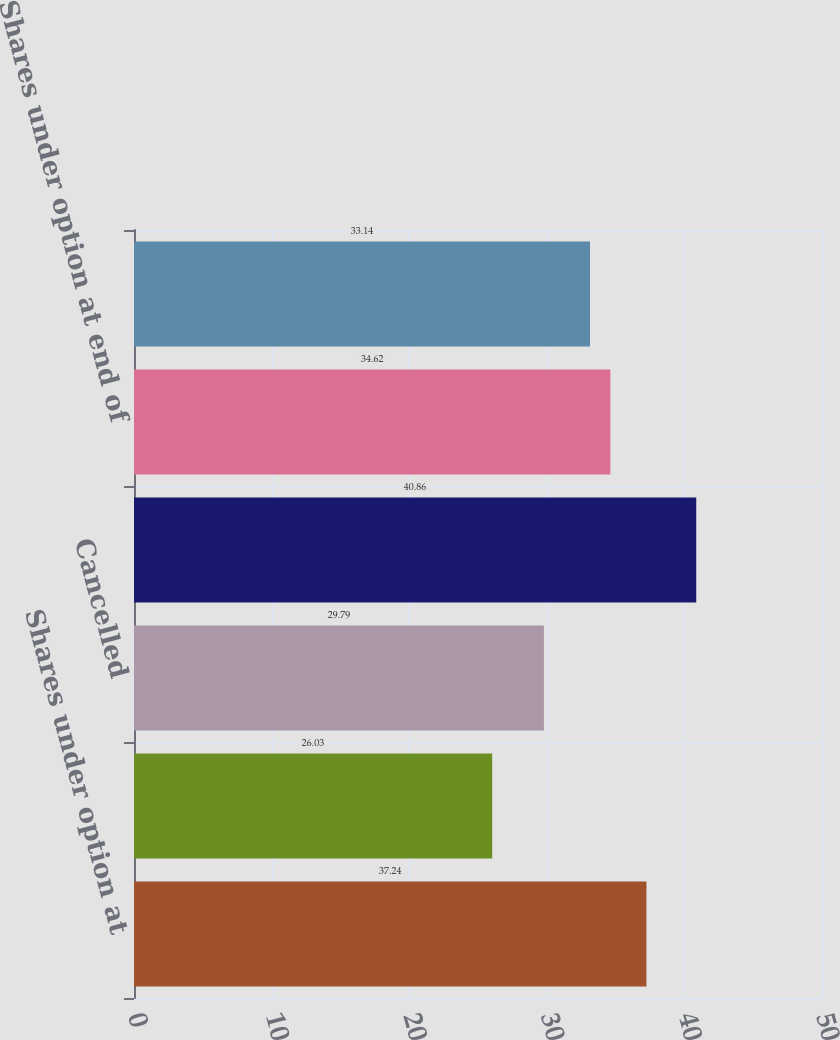Convert chart to OTSL. <chart><loc_0><loc_0><loc_500><loc_500><bar_chart><fcel>Shares under option at<fcel>Granted<fcel>Cancelled<fcel>Exercised<fcel>Shares under option at end of<fcel>Exercisable at end of year<nl><fcel>37.24<fcel>26.03<fcel>29.79<fcel>40.86<fcel>34.62<fcel>33.14<nl></chart> 